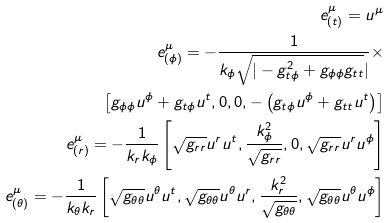Convert formula to latex. <formula><loc_0><loc_0><loc_500><loc_500>e ^ { \mu } _ { ( t ) } = u ^ { \mu } \\ e ^ { \mu } _ { ( \phi ) } = - \frac { 1 } { k _ { \phi } \sqrt { | - g ^ { 2 } _ { t \phi } + g _ { \phi \phi } g _ { t t } } | } \times \\ \left [ g _ { \phi \phi } u ^ { \phi } + g _ { t \phi } u ^ { t } , 0 , 0 , - \left ( g _ { t \phi } u ^ { \phi } + g _ { t t } u ^ { t } \right ) \right ] \\ e ^ { \mu } _ { ( r ) } = - \frac { 1 } { k _ { r } k _ { \phi } } \left [ \sqrt { g _ { r r } } u ^ { r } u ^ { t } , \frac { k ^ { 2 } _ { \phi } } { \sqrt { g _ { r r } } } , 0 , \sqrt { g _ { r r } } u ^ { r } u ^ { \phi } \right ] \\ e ^ { \mu } _ { ( \theta ) } = - \frac { 1 } { k _ { \theta } k _ { r } } \left [ \sqrt { g _ { \theta \theta } } u ^ { \theta } u ^ { t } , \sqrt { g _ { \theta \theta } } u ^ { \theta } u ^ { r } , \frac { k ^ { 2 } _ { r } } { \sqrt { g _ { \theta \theta } } } , \sqrt { g _ { \theta \theta } } u ^ { \theta } u ^ { \phi } \right ]</formula> 